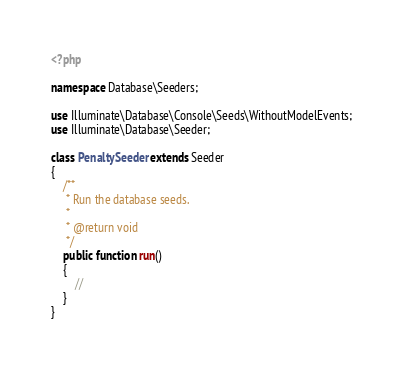<code> <loc_0><loc_0><loc_500><loc_500><_PHP_><?php

namespace Database\Seeders;

use Illuminate\Database\Console\Seeds\WithoutModelEvents;
use Illuminate\Database\Seeder;

class PenaltySeeder extends Seeder
{
    /**
     * Run the database seeds.
     *
     * @return void
     */
    public function run()
    {
        //
    }
}
</code> 